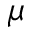Convert formula to latex. <formula><loc_0><loc_0><loc_500><loc_500>\mu</formula> 